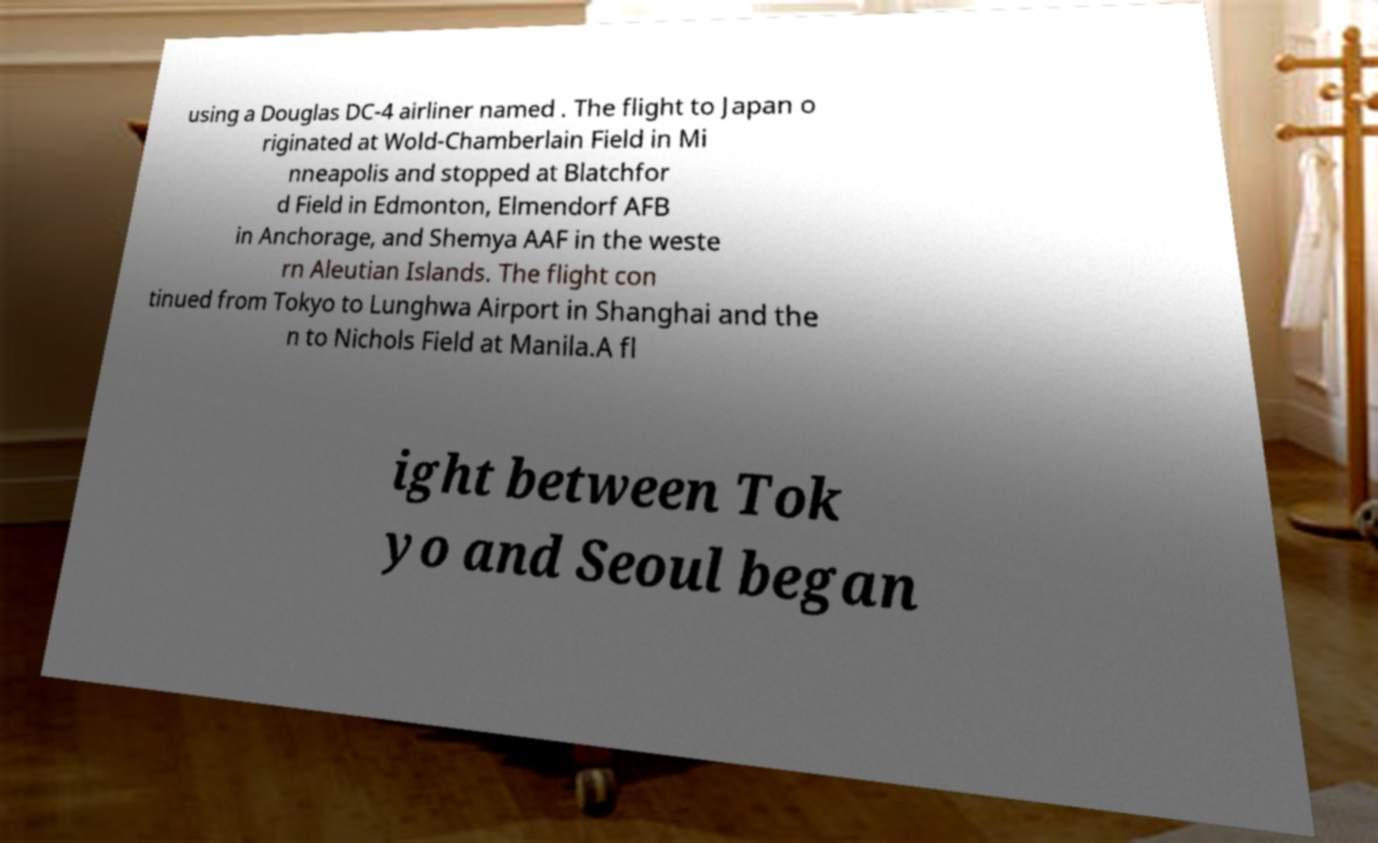Please identify and transcribe the text found in this image. using a Douglas DC-4 airliner named . The flight to Japan o riginated at Wold-Chamberlain Field in Mi nneapolis and stopped at Blatchfor d Field in Edmonton, Elmendorf AFB in Anchorage, and Shemya AAF in the weste rn Aleutian Islands. The flight con tinued from Tokyo to Lunghwa Airport in Shanghai and the n to Nichols Field at Manila.A fl ight between Tok yo and Seoul began 